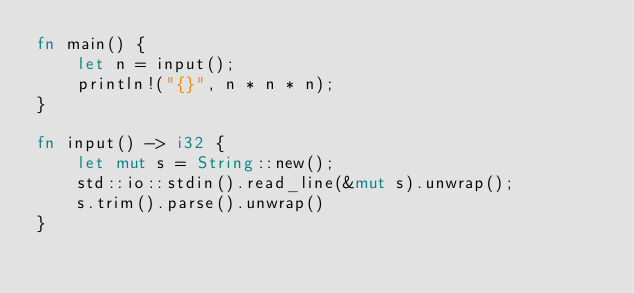<code> <loc_0><loc_0><loc_500><loc_500><_Rust_>fn main() {
    let n = input();
    println!("{}", n * n * n);
}

fn input() -> i32 {
    let mut s = String::new();
    std::io::stdin().read_line(&mut s).unwrap();
    s.trim().parse().unwrap()
}

</code> 